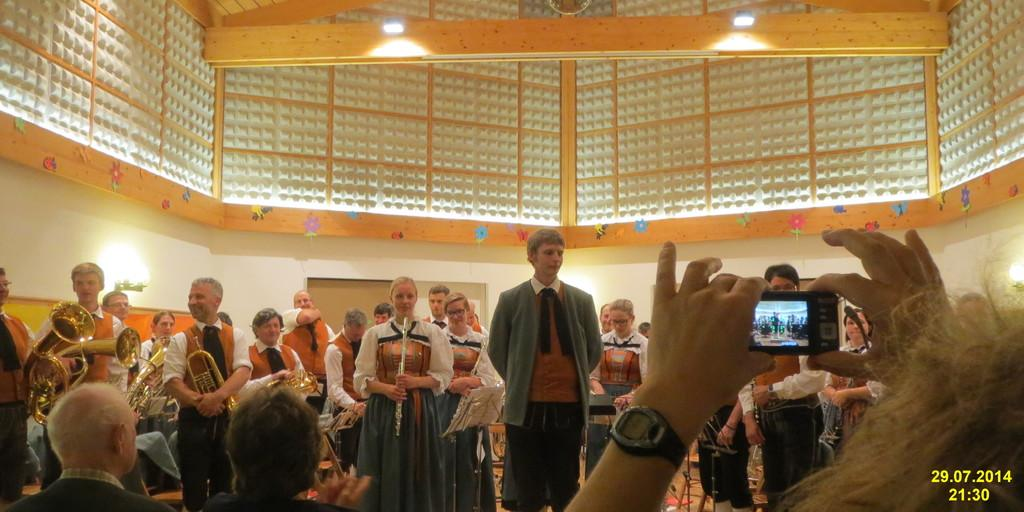<image>
Render a clear and concise summary of the photo. people in cultural dress standing in a hall with a date stamp of 29.07.2014 